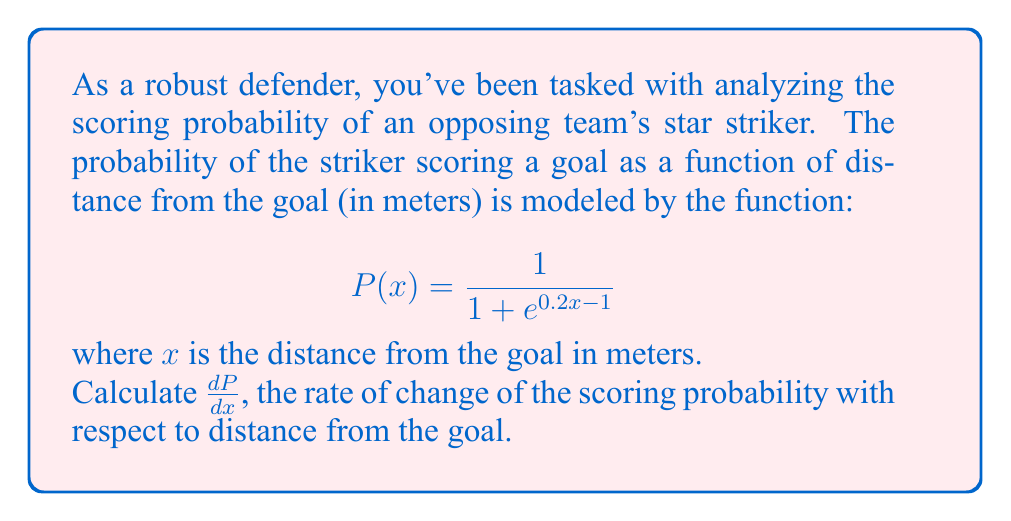Provide a solution to this math problem. To find $\frac{dP}{dx}$, we need to differentiate $P(x)$ with respect to $x$. Let's approach this step-by-step:

1) First, recognize that $P(x)$ is in the form of a logistic function: $\frac{1}{1 + e^{-k(x-x_0)}}$, where $k = -0.2$ and $x_0 = 5$.

2) The derivative of a logistic function is given by:

   $$\frac{d}{dx}\left(\frac{1}{1 + e^{-k(x-x_0)}}\right) = \frac{ke^{-k(x-x_0)}}{(1 + e^{-k(x-x_0)})^2}$$

3) In our case, we have $-k(x-x_0) = 0.2x - 1$, so $k = -0.2$

4) Substituting this into the derivative formula:

   $$\frac{dP}{dx} = \frac{-0.2e^{0.2x - 1}}{(1 + e^{0.2x - 1})^2}$$

5) We can simplify this slightly:

   $$\frac{dP}{dx} = -0.2 \cdot \frac{e^{0.2x - 1}}{(1 + e^{0.2x - 1})^2}$$

6) Recognize that $\frac{e^{0.2x - 1}}{1 + e^{0.2x - 1}} = 1 - P(x)$

7) Therefore, we can express the final result as:

   $$\frac{dP}{dx} = -0.2P(x)(1-P(x))$$

This form is particularly useful as it expresses the rate of change in terms of the original function $P(x)$.
Answer: $$\frac{dP}{dx} = -0.2P(x)(1-P(x))$$ 